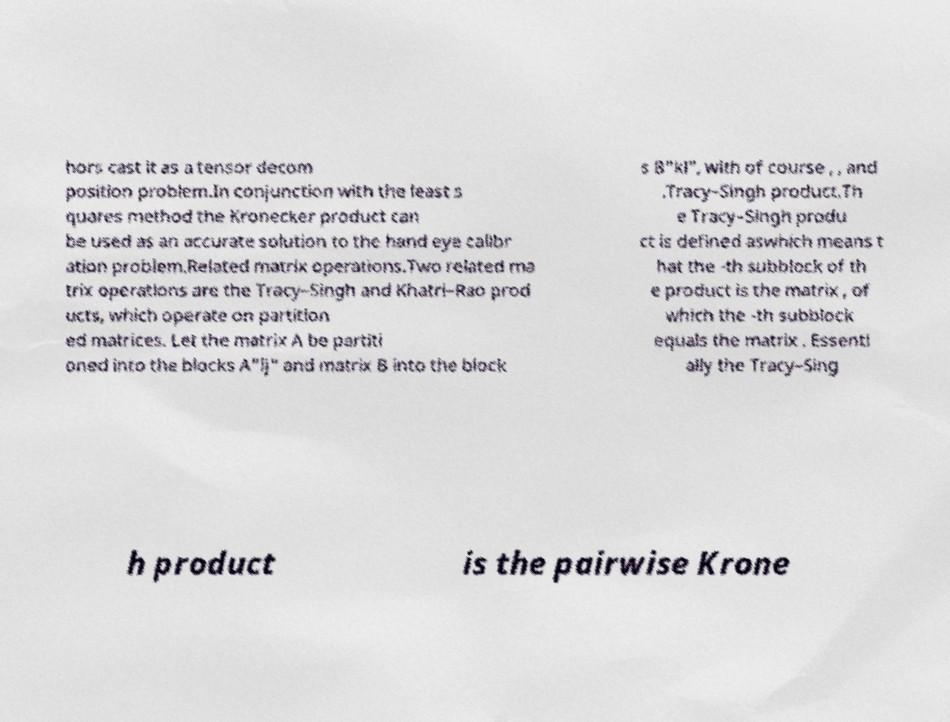Could you assist in decoding the text presented in this image and type it out clearly? hors cast it as a tensor decom position problem.In conjunction with the least s quares method the Kronecker product can be used as an accurate solution to the hand eye calibr ation problem.Related matrix operations.Two related ma trix operations are the Tracy–Singh and Khatri–Rao prod ucts, which operate on partition ed matrices. Let the matrix A be partiti oned into the blocks A"ij" and matrix B into the block s B"kl", with of course , , and .Tracy–Singh product.Th e Tracy–Singh produ ct is defined aswhich means t hat the -th subblock of th e product is the matrix , of which the -th subblock equals the matrix . Essenti ally the Tracy–Sing h product is the pairwise Krone 